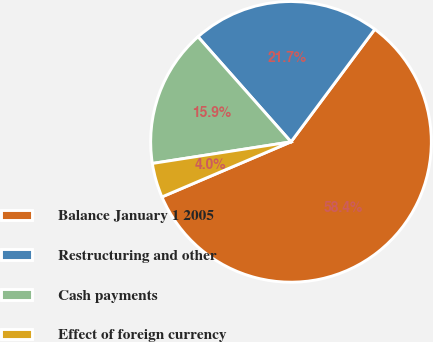Convert chart. <chart><loc_0><loc_0><loc_500><loc_500><pie_chart><fcel>Balance January 1 2005<fcel>Restructuring and other<fcel>Cash payments<fcel>Effect of foreign currency<nl><fcel>58.4%<fcel>21.71%<fcel>15.93%<fcel>3.96%<nl></chart> 